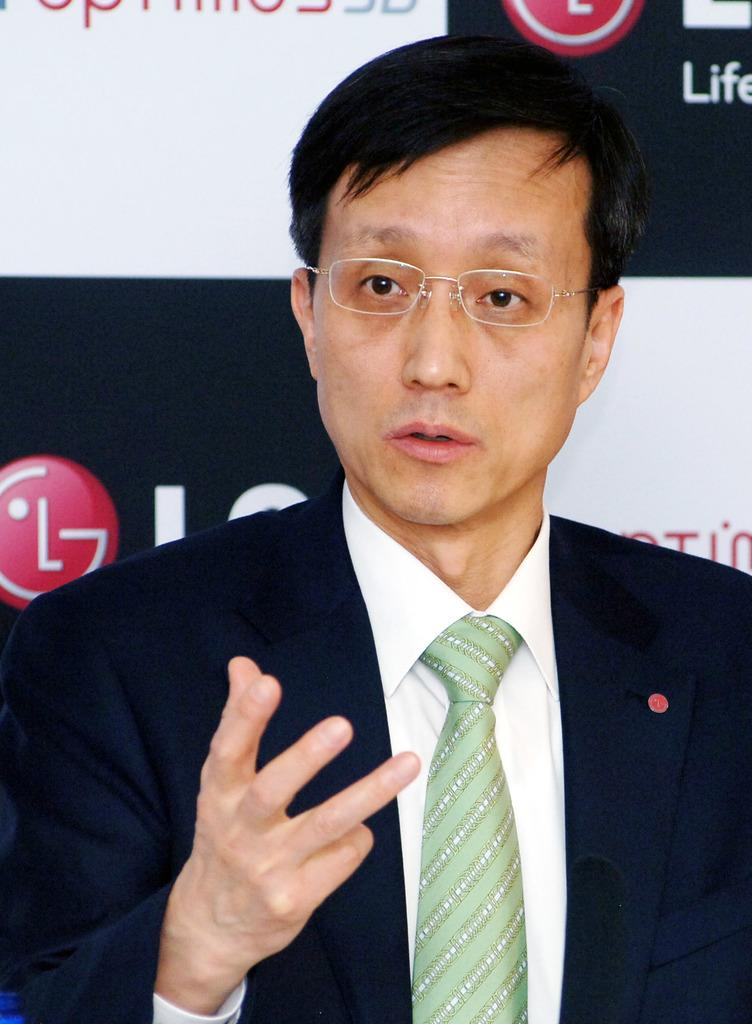What can be seen in the image? There is a person in the image. Can you describe the person's appearance? The person is wearing spectacles. What is the person doing in the image? The person is talking. What else is present in the image besides the person? There is a board with text and a logo in the image. What type of root can be seen growing from the person's head in the image? There is no root growing from the person's head in the image. How many points does the logo on the board have in the image? The provided facts do not mention the number of points on the logo, so we cannot answer that question definitively. 